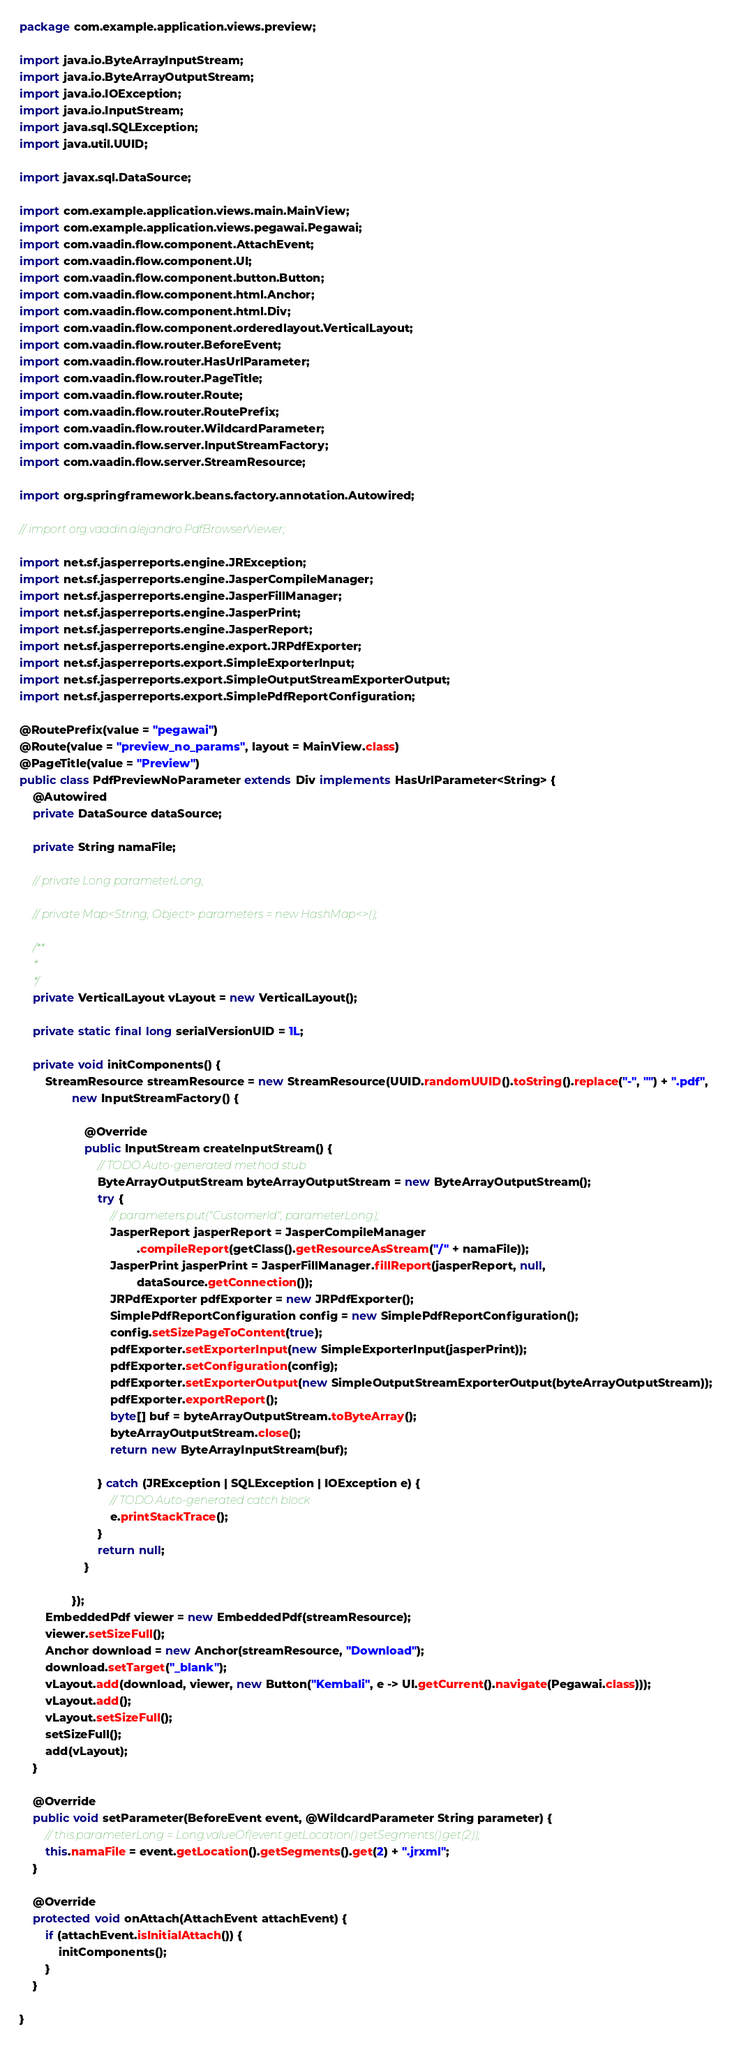<code> <loc_0><loc_0><loc_500><loc_500><_Java_>package com.example.application.views.preview;

import java.io.ByteArrayInputStream;
import java.io.ByteArrayOutputStream;
import java.io.IOException;
import java.io.InputStream;
import java.sql.SQLException;
import java.util.UUID;

import javax.sql.DataSource;

import com.example.application.views.main.MainView;
import com.example.application.views.pegawai.Pegawai;
import com.vaadin.flow.component.AttachEvent;
import com.vaadin.flow.component.UI;
import com.vaadin.flow.component.button.Button;
import com.vaadin.flow.component.html.Anchor;
import com.vaadin.flow.component.html.Div;
import com.vaadin.flow.component.orderedlayout.VerticalLayout;
import com.vaadin.flow.router.BeforeEvent;
import com.vaadin.flow.router.HasUrlParameter;
import com.vaadin.flow.router.PageTitle;
import com.vaadin.flow.router.Route;
import com.vaadin.flow.router.RoutePrefix;
import com.vaadin.flow.router.WildcardParameter;
import com.vaadin.flow.server.InputStreamFactory;
import com.vaadin.flow.server.StreamResource;

import org.springframework.beans.factory.annotation.Autowired;

// import org.vaadin.alejandro.PdfBrowserViewer;

import net.sf.jasperreports.engine.JRException;
import net.sf.jasperreports.engine.JasperCompileManager;
import net.sf.jasperreports.engine.JasperFillManager;
import net.sf.jasperreports.engine.JasperPrint;
import net.sf.jasperreports.engine.JasperReport;
import net.sf.jasperreports.engine.export.JRPdfExporter;
import net.sf.jasperreports.export.SimpleExporterInput;
import net.sf.jasperreports.export.SimpleOutputStreamExporterOutput;
import net.sf.jasperreports.export.SimplePdfReportConfiguration;

@RoutePrefix(value = "pegawai")
@Route(value = "preview_no_params", layout = MainView.class)
@PageTitle(value = "Preview")
public class PdfPreviewNoParameter extends Div implements HasUrlParameter<String> {
    @Autowired
    private DataSource dataSource;

    private String namaFile;

    // private Long parameterLong;

    // private Map<String, Object> parameters = new HashMap<>();

    /**
     *
     */
    private VerticalLayout vLayout = new VerticalLayout();

    private static final long serialVersionUID = 1L;

    private void initComponents() {
        StreamResource streamResource = new StreamResource(UUID.randomUUID().toString().replace("-", "") + ".pdf",
                new InputStreamFactory() {

                    @Override
                    public InputStream createInputStream() {
                        // TODO Auto-generated method stub
                        ByteArrayOutputStream byteArrayOutputStream = new ByteArrayOutputStream();
                        try {
                            // parameters.put("CustomerId", parameterLong);
                            JasperReport jasperReport = JasperCompileManager
                                    .compileReport(getClass().getResourceAsStream("/" + namaFile));
                            JasperPrint jasperPrint = JasperFillManager.fillReport(jasperReport, null,
                                    dataSource.getConnection());
                            JRPdfExporter pdfExporter = new JRPdfExporter();
                            SimplePdfReportConfiguration config = new SimplePdfReportConfiguration();
                            config.setSizePageToContent(true);
                            pdfExporter.setExporterInput(new SimpleExporterInput(jasperPrint));
                            pdfExporter.setConfiguration(config);
                            pdfExporter.setExporterOutput(new SimpleOutputStreamExporterOutput(byteArrayOutputStream));
                            pdfExporter.exportReport();
                            byte[] buf = byteArrayOutputStream.toByteArray();
                            byteArrayOutputStream.close();
                            return new ByteArrayInputStream(buf);

                        } catch (JRException | SQLException | IOException e) {
                            // TODO Auto-generated catch block
                            e.printStackTrace();
                        }
                        return null;
                    }

                });
        EmbeddedPdf viewer = new EmbeddedPdf(streamResource);
        viewer.setSizeFull();
        Anchor download = new Anchor(streamResource, "Download");
        download.setTarget("_blank");
        vLayout.add(download, viewer, new Button("Kembali", e -> UI.getCurrent().navigate(Pegawai.class)));
        vLayout.add();
        vLayout.setSizeFull();
        setSizeFull();
        add(vLayout);
    }

    @Override
    public void setParameter(BeforeEvent event, @WildcardParameter String parameter) {
        // this.parameterLong = Long.valueOf(event.getLocation().getSegments().get(2));
        this.namaFile = event.getLocation().getSegments().get(2) + ".jrxml";
    }

    @Override
    protected void onAttach(AttachEvent attachEvent) {
        if (attachEvent.isInitialAttach()) {
            initComponents();
        }
    }

}
</code> 